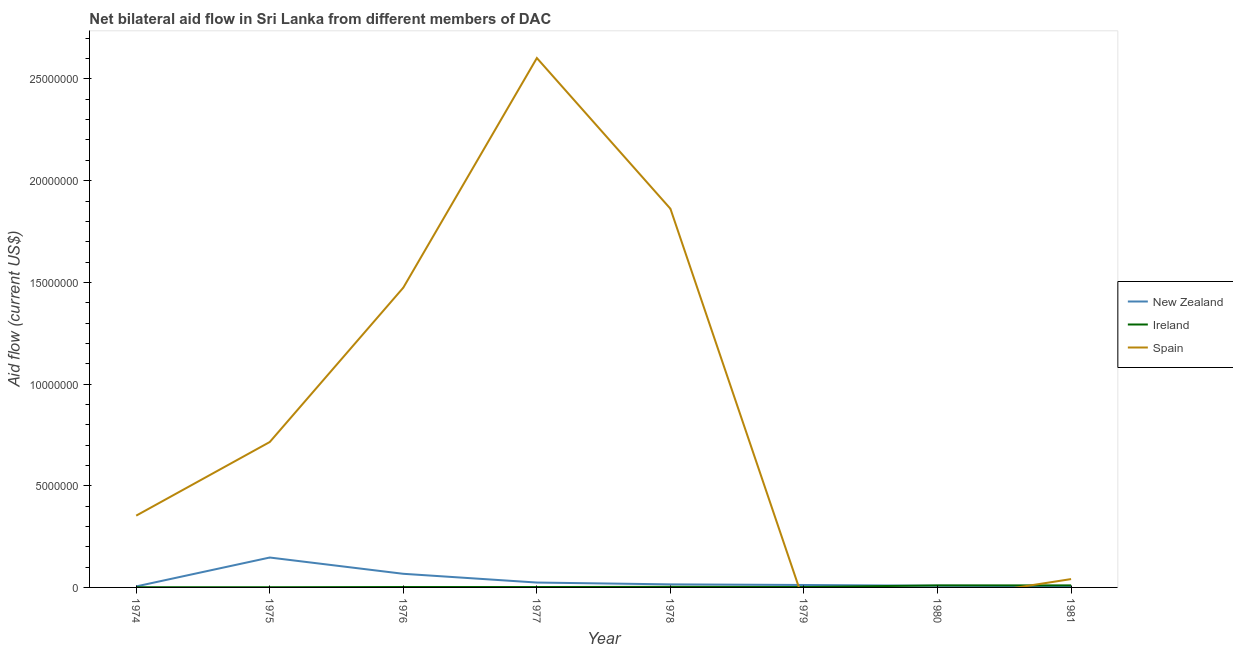How many different coloured lines are there?
Provide a succinct answer. 3. What is the amount of aid provided by new zealand in 1980?
Keep it short and to the point. 8.00e+04. Across all years, what is the maximum amount of aid provided by spain?
Offer a very short reply. 2.60e+07. Across all years, what is the minimum amount of aid provided by ireland?
Your response must be concise. 10000. In which year was the amount of aid provided by new zealand maximum?
Your answer should be compact. 1975. What is the total amount of aid provided by spain in the graph?
Provide a short and direct response. 7.05e+07. What is the difference between the amount of aid provided by ireland in 1974 and that in 1981?
Give a very brief answer. -9.00e+04. What is the difference between the amount of aid provided by spain in 1979 and the amount of aid provided by ireland in 1975?
Your answer should be compact. -10000. What is the average amount of aid provided by new zealand per year?
Make the answer very short. 3.55e+05. In the year 1978, what is the difference between the amount of aid provided by new zealand and amount of aid provided by spain?
Your answer should be very brief. -1.85e+07. In how many years, is the amount of aid provided by new zealand greater than 22000000 US$?
Ensure brevity in your answer.  0. Is the difference between the amount of aid provided by new zealand in 1976 and 1977 greater than the difference between the amount of aid provided by ireland in 1976 and 1977?
Your answer should be very brief. Yes. What is the difference between the highest and the second highest amount of aid provided by spain?
Your answer should be very brief. 7.41e+06. What is the difference between the highest and the lowest amount of aid provided by spain?
Your response must be concise. 2.60e+07. Is the sum of the amount of aid provided by ireland in 1975 and 1978 greater than the maximum amount of aid provided by new zealand across all years?
Your answer should be very brief. No. Does the amount of aid provided by ireland monotonically increase over the years?
Offer a very short reply. No. Is the amount of aid provided by spain strictly less than the amount of aid provided by ireland over the years?
Provide a short and direct response. No. How many years are there in the graph?
Your response must be concise. 8. Does the graph contain any zero values?
Provide a short and direct response. Yes. Does the graph contain grids?
Keep it short and to the point. No. Where does the legend appear in the graph?
Ensure brevity in your answer.  Center right. How are the legend labels stacked?
Provide a short and direct response. Vertical. What is the title of the graph?
Your answer should be very brief. Net bilateral aid flow in Sri Lanka from different members of DAC. What is the label or title of the Y-axis?
Your answer should be very brief. Aid flow (current US$). What is the Aid flow (current US$) in New Zealand in 1974?
Make the answer very short. 5.00e+04. What is the Aid flow (current US$) in Spain in 1974?
Make the answer very short. 3.53e+06. What is the Aid flow (current US$) of New Zealand in 1975?
Make the answer very short. 1.47e+06. What is the Aid flow (current US$) in Ireland in 1975?
Give a very brief answer. 10000. What is the Aid flow (current US$) in Spain in 1975?
Your answer should be very brief. 7.15e+06. What is the Aid flow (current US$) of New Zealand in 1976?
Keep it short and to the point. 6.70e+05. What is the Aid flow (current US$) of Spain in 1976?
Provide a short and direct response. 1.47e+07. What is the Aid flow (current US$) in Ireland in 1977?
Your answer should be compact. 2.00e+04. What is the Aid flow (current US$) in Spain in 1977?
Keep it short and to the point. 2.60e+07. What is the Aid flow (current US$) of Ireland in 1978?
Your answer should be compact. 3.00e+04. What is the Aid flow (current US$) of Spain in 1978?
Offer a terse response. 1.86e+07. What is the Aid flow (current US$) of Ireland in 1979?
Offer a terse response. 2.00e+04. What is the Aid flow (current US$) of New Zealand in 1980?
Give a very brief answer. 8.00e+04. What is the Aid flow (current US$) of Ireland in 1980?
Ensure brevity in your answer.  1.00e+05. What is the Aid flow (current US$) of Spain in 1980?
Offer a terse response. 0. What is the Aid flow (current US$) of New Zealand in 1981?
Give a very brief answer. 6.00e+04. What is the Aid flow (current US$) of Ireland in 1981?
Your answer should be very brief. 1.00e+05. Across all years, what is the maximum Aid flow (current US$) in New Zealand?
Your answer should be very brief. 1.47e+06. Across all years, what is the maximum Aid flow (current US$) of Spain?
Make the answer very short. 2.60e+07. Across all years, what is the minimum Aid flow (current US$) in New Zealand?
Ensure brevity in your answer.  5.00e+04. Across all years, what is the minimum Aid flow (current US$) in Spain?
Provide a succinct answer. 0. What is the total Aid flow (current US$) of New Zealand in the graph?
Your answer should be compact. 2.84e+06. What is the total Aid flow (current US$) in Ireland in the graph?
Offer a very short reply. 3.10e+05. What is the total Aid flow (current US$) of Spain in the graph?
Your answer should be very brief. 7.05e+07. What is the difference between the Aid flow (current US$) in New Zealand in 1974 and that in 1975?
Your answer should be compact. -1.42e+06. What is the difference between the Aid flow (current US$) of Ireland in 1974 and that in 1975?
Offer a very short reply. 0. What is the difference between the Aid flow (current US$) of Spain in 1974 and that in 1975?
Provide a short and direct response. -3.62e+06. What is the difference between the Aid flow (current US$) of New Zealand in 1974 and that in 1976?
Ensure brevity in your answer.  -6.20e+05. What is the difference between the Aid flow (current US$) in Ireland in 1974 and that in 1976?
Provide a short and direct response. -10000. What is the difference between the Aid flow (current US$) in Spain in 1974 and that in 1976?
Offer a very short reply. -1.12e+07. What is the difference between the Aid flow (current US$) of New Zealand in 1974 and that in 1977?
Provide a succinct answer. -1.90e+05. What is the difference between the Aid flow (current US$) in Spain in 1974 and that in 1977?
Your answer should be compact. -2.25e+07. What is the difference between the Aid flow (current US$) of New Zealand in 1974 and that in 1978?
Give a very brief answer. -1.00e+05. What is the difference between the Aid flow (current US$) in Ireland in 1974 and that in 1978?
Offer a very short reply. -2.00e+04. What is the difference between the Aid flow (current US$) in Spain in 1974 and that in 1978?
Your response must be concise. -1.51e+07. What is the difference between the Aid flow (current US$) of Ireland in 1974 and that in 1980?
Your response must be concise. -9.00e+04. What is the difference between the Aid flow (current US$) of Spain in 1974 and that in 1981?
Make the answer very short. 3.12e+06. What is the difference between the Aid flow (current US$) in New Zealand in 1975 and that in 1976?
Your answer should be compact. 8.00e+05. What is the difference between the Aid flow (current US$) of Spain in 1975 and that in 1976?
Provide a succinct answer. -7.59e+06. What is the difference between the Aid flow (current US$) of New Zealand in 1975 and that in 1977?
Provide a succinct answer. 1.23e+06. What is the difference between the Aid flow (current US$) of Ireland in 1975 and that in 1977?
Offer a terse response. -10000. What is the difference between the Aid flow (current US$) in Spain in 1975 and that in 1977?
Offer a very short reply. -1.89e+07. What is the difference between the Aid flow (current US$) in New Zealand in 1975 and that in 1978?
Your response must be concise. 1.32e+06. What is the difference between the Aid flow (current US$) of Ireland in 1975 and that in 1978?
Offer a terse response. -2.00e+04. What is the difference between the Aid flow (current US$) in Spain in 1975 and that in 1978?
Provide a short and direct response. -1.15e+07. What is the difference between the Aid flow (current US$) in New Zealand in 1975 and that in 1979?
Your response must be concise. 1.35e+06. What is the difference between the Aid flow (current US$) in New Zealand in 1975 and that in 1980?
Provide a short and direct response. 1.39e+06. What is the difference between the Aid flow (current US$) in Ireland in 1975 and that in 1980?
Your answer should be compact. -9.00e+04. What is the difference between the Aid flow (current US$) of New Zealand in 1975 and that in 1981?
Your answer should be compact. 1.41e+06. What is the difference between the Aid flow (current US$) of Spain in 1975 and that in 1981?
Offer a very short reply. 6.74e+06. What is the difference between the Aid flow (current US$) of New Zealand in 1976 and that in 1977?
Your answer should be compact. 4.30e+05. What is the difference between the Aid flow (current US$) of Ireland in 1976 and that in 1977?
Keep it short and to the point. 0. What is the difference between the Aid flow (current US$) in Spain in 1976 and that in 1977?
Offer a very short reply. -1.13e+07. What is the difference between the Aid flow (current US$) of New Zealand in 1976 and that in 1978?
Keep it short and to the point. 5.20e+05. What is the difference between the Aid flow (current US$) of Spain in 1976 and that in 1978?
Your answer should be compact. -3.88e+06. What is the difference between the Aid flow (current US$) in New Zealand in 1976 and that in 1980?
Provide a succinct answer. 5.90e+05. What is the difference between the Aid flow (current US$) of Ireland in 1976 and that in 1981?
Ensure brevity in your answer.  -8.00e+04. What is the difference between the Aid flow (current US$) of Spain in 1976 and that in 1981?
Ensure brevity in your answer.  1.43e+07. What is the difference between the Aid flow (current US$) in Spain in 1977 and that in 1978?
Your response must be concise. 7.41e+06. What is the difference between the Aid flow (current US$) in New Zealand in 1977 and that in 1979?
Your answer should be compact. 1.20e+05. What is the difference between the Aid flow (current US$) of New Zealand in 1977 and that in 1981?
Offer a very short reply. 1.80e+05. What is the difference between the Aid flow (current US$) in Ireland in 1977 and that in 1981?
Provide a short and direct response. -8.00e+04. What is the difference between the Aid flow (current US$) in Spain in 1977 and that in 1981?
Your answer should be very brief. 2.56e+07. What is the difference between the Aid flow (current US$) of New Zealand in 1978 and that in 1979?
Provide a succinct answer. 3.00e+04. What is the difference between the Aid flow (current US$) of Ireland in 1978 and that in 1980?
Provide a short and direct response. -7.00e+04. What is the difference between the Aid flow (current US$) in Ireland in 1978 and that in 1981?
Offer a terse response. -7.00e+04. What is the difference between the Aid flow (current US$) in Spain in 1978 and that in 1981?
Offer a very short reply. 1.82e+07. What is the difference between the Aid flow (current US$) of New Zealand in 1979 and that in 1980?
Your response must be concise. 4.00e+04. What is the difference between the Aid flow (current US$) of Ireland in 1979 and that in 1980?
Keep it short and to the point. -8.00e+04. What is the difference between the Aid flow (current US$) of New Zealand in 1979 and that in 1981?
Ensure brevity in your answer.  6.00e+04. What is the difference between the Aid flow (current US$) in Ireland in 1979 and that in 1981?
Offer a very short reply. -8.00e+04. What is the difference between the Aid flow (current US$) in New Zealand in 1974 and the Aid flow (current US$) in Ireland in 1975?
Provide a short and direct response. 4.00e+04. What is the difference between the Aid flow (current US$) of New Zealand in 1974 and the Aid flow (current US$) of Spain in 1975?
Your response must be concise. -7.10e+06. What is the difference between the Aid flow (current US$) in Ireland in 1974 and the Aid flow (current US$) in Spain in 1975?
Make the answer very short. -7.14e+06. What is the difference between the Aid flow (current US$) of New Zealand in 1974 and the Aid flow (current US$) of Ireland in 1976?
Give a very brief answer. 3.00e+04. What is the difference between the Aid flow (current US$) in New Zealand in 1974 and the Aid flow (current US$) in Spain in 1976?
Offer a very short reply. -1.47e+07. What is the difference between the Aid flow (current US$) of Ireland in 1974 and the Aid flow (current US$) of Spain in 1976?
Offer a very short reply. -1.47e+07. What is the difference between the Aid flow (current US$) of New Zealand in 1974 and the Aid flow (current US$) of Spain in 1977?
Your response must be concise. -2.60e+07. What is the difference between the Aid flow (current US$) of Ireland in 1974 and the Aid flow (current US$) of Spain in 1977?
Your answer should be very brief. -2.60e+07. What is the difference between the Aid flow (current US$) in New Zealand in 1974 and the Aid flow (current US$) in Spain in 1978?
Ensure brevity in your answer.  -1.86e+07. What is the difference between the Aid flow (current US$) of Ireland in 1974 and the Aid flow (current US$) of Spain in 1978?
Offer a terse response. -1.86e+07. What is the difference between the Aid flow (current US$) of New Zealand in 1974 and the Aid flow (current US$) of Ireland in 1979?
Give a very brief answer. 3.00e+04. What is the difference between the Aid flow (current US$) in New Zealand in 1974 and the Aid flow (current US$) in Ireland in 1981?
Your answer should be compact. -5.00e+04. What is the difference between the Aid flow (current US$) of New Zealand in 1974 and the Aid flow (current US$) of Spain in 1981?
Provide a short and direct response. -3.60e+05. What is the difference between the Aid flow (current US$) of Ireland in 1974 and the Aid flow (current US$) of Spain in 1981?
Ensure brevity in your answer.  -4.00e+05. What is the difference between the Aid flow (current US$) in New Zealand in 1975 and the Aid flow (current US$) in Ireland in 1976?
Make the answer very short. 1.45e+06. What is the difference between the Aid flow (current US$) of New Zealand in 1975 and the Aid flow (current US$) of Spain in 1976?
Offer a terse response. -1.33e+07. What is the difference between the Aid flow (current US$) of Ireland in 1975 and the Aid flow (current US$) of Spain in 1976?
Your response must be concise. -1.47e+07. What is the difference between the Aid flow (current US$) in New Zealand in 1975 and the Aid flow (current US$) in Ireland in 1977?
Make the answer very short. 1.45e+06. What is the difference between the Aid flow (current US$) in New Zealand in 1975 and the Aid flow (current US$) in Spain in 1977?
Make the answer very short. -2.46e+07. What is the difference between the Aid flow (current US$) of Ireland in 1975 and the Aid flow (current US$) of Spain in 1977?
Your answer should be very brief. -2.60e+07. What is the difference between the Aid flow (current US$) in New Zealand in 1975 and the Aid flow (current US$) in Ireland in 1978?
Ensure brevity in your answer.  1.44e+06. What is the difference between the Aid flow (current US$) of New Zealand in 1975 and the Aid flow (current US$) of Spain in 1978?
Give a very brief answer. -1.72e+07. What is the difference between the Aid flow (current US$) in Ireland in 1975 and the Aid flow (current US$) in Spain in 1978?
Keep it short and to the point. -1.86e+07. What is the difference between the Aid flow (current US$) of New Zealand in 1975 and the Aid flow (current US$) of Ireland in 1979?
Keep it short and to the point. 1.45e+06. What is the difference between the Aid flow (current US$) of New Zealand in 1975 and the Aid flow (current US$) of Ireland in 1980?
Provide a short and direct response. 1.37e+06. What is the difference between the Aid flow (current US$) in New Zealand in 1975 and the Aid flow (current US$) in Ireland in 1981?
Provide a succinct answer. 1.37e+06. What is the difference between the Aid flow (current US$) in New Zealand in 1975 and the Aid flow (current US$) in Spain in 1981?
Provide a succinct answer. 1.06e+06. What is the difference between the Aid flow (current US$) in Ireland in 1975 and the Aid flow (current US$) in Spain in 1981?
Your answer should be very brief. -4.00e+05. What is the difference between the Aid flow (current US$) of New Zealand in 1976 and the Aid flow (current US$) of Ireland in 1977?
Ensure brevity in your answer.  6.50e+05. What is the difference between the Aid flow (current US$) of New Zealand in 1976 and the Aid flow (current US$) of Spain in 1977?
Your answer should be compact. -2.54e+07. What is the difference between the Aid flow (current US$) of Ireland in 1976 and the Aid flow (current US$) of Spain in 1977?
Offer a very short reply. -2.60e+07. What is the difference between the Aid flow (current US$) in New Zealand in 1976 and the Aid flow (current US$) in Ireland in 1978?
Make the answer very short. 6.40e+05. What is the difference between the Aid flow (current US$) of New Zealand in 1976 and the Aid flow (current US$) of Spain in 1978?
Your answer should be compact. -1.80e+07. What is the difference between the Aid flow (current US$) in Ireland in 1976 and the Aid flow (current US$) in Spain in 1978?
Your answer should be very brief. -1.86e+07. What is the difference between the Aid flow (current US$) of New Zealand in 1976 and the Aid flow (current US$) of Ireland in 1979?
Ensure brevity in your answer.  6.50e+05. What is the difference between the Aid flow (current US$) of New Zealand in 1976 and the Aid flow (current US$) of Ireland in 1980?
Offer a very short reply. 5.70e+05. What is the difference between the Aid flow (current US$) in New Zealand in 1976 and the Aid flow (current US$) in Ireland in 1981?
Your answer should be compact. 5.70e+05. What is the difference between the Aid flow (current US$) of Ireland in 1976 and the Aid flow (current US$) of Spain in 1981?
Keep it short and to the point. -3.90e+05. What is the difference between the Aid flow (current US$) of New Zealand in 1977 and the Aid flow (current US$) of Ireland in 1978?
Keep it short and to the point. 2.10e+05. What is the difference between the Aid flow (current US$) in New Zealand in 1977 and the Aid flow (current US$) in Spain in 1978?
Ensure brevity in your answer.  -1.84e+07. What is the difference between the Aid flow (current US$) in Ireland in 1977 and the Aid flow (current US$) in Spain in 1978?
Offer a very short reply. -1.86e+07. What is the difference between the Aid flow (current US$) in New Zealand in 1977 and the Aid flow (current US$) in Ireland in 1979?
Your answer should be very brief. 2.20e+05. What is the difference between the Aid flow (current US$) in New Zealand in 1977 and the Aid flow (current US$) in Spain in 1981?
Make the answer very short. -1.70e+05. What is the difference between the Aid flow (current US$) of Ireland in 1977 and the Aid flow (current US$) of Spain in 1981?
Your response must be concise. -3.90e+05. What is the difference between the Aid flow (current US$) of New Zealand in 1978 and the Aid flow (current US$) of Ireland in 1979?
Provide a succinct answer. 1.30e+05. What is the difference between the Aid flow (current US$) in New Zealand in 1978 and the Aid flow (current US$) in Ireland in 1981?
Give a very brief answer. 5.00e+04. What is the difference between the Aid flow (current US$) of Ireland in 1978 and the Aid flow (current US$) of Spain in 1981?
Offer a terse response. -3.80e+05. What is the difference between the Aid flow (current US$) of New Zealand in 1979 and the Aid flow (current US$) of Ireland in 1980?
Offer a terse response. 2.00e+04. What is the difference between the Aid flow (current US$) in Ireland in 1979 and the Aid flow (current US$) in Spain in 1981?
Offer a very short reply. -3.90e+05. What is the difference between the Aid flow (current US$) in New Zealand in 1980 and the Aid flow (current US$) in Ireland in 1981?
Your answer should be compact. -2.00e+04. What is the difference between the Aid flow (current US$) in New Zealand in 1980 and the Aid flow (current US$) in Spain in 1981?
Provide a short and direct response. -3.30e+05. What is the difference between the Aid flow (current US$) of Ireland in 1980 and the Aid flow (current US$) of Spain in 1981?
Ensure brevity in your answer.  -3.10e+05. What is the average Aid flow (current US$) of New Zealand per year?
Ensure brevity in your answer.  3.55e+05. What is the average Aid flow (current US$) of Ireland per year?
Provide a short and direct response. 3.88e+04. What is the average Aid flow (current US$) in Spain per year?
Your response must be concise. 8.81e+06. In the year 1974, what is the difference between the Aid flow (current US$) in New Zealand and Aid flow (current US$) in Ireland?
Give a very brief answer. 4.00e+04. In the year 1974, what is the difference between the Aid flow (current US$) of New Zealand and Aid flow (current US$) of Spain?
Make the answer very short. -3.48e+06. In the year 1974, what is the difference between the Aid flow (current US$) of Ireland and Aid flow (current US$) of Spain?
Keep it short and to the point. -3.52e+06. In the year 1975, what is the difference between the Aid flow (current US$) in New Zealand and Aid flow (current US$) in Ireland?
Offer a very short reply. 1.46e+06. In the year 1975, what is the difference between the Aid flow (current US$) of New Zealand and Aid flow (current US$) of Spain?
Keep it short and to the point. -5.68e+06. In the year 1975, what is the difference between the Aid flow (current US$) of Ireland and Aid flow (current US$) of Spain?
Make the answer very short. -7.14e+06. In the year 1976, what is the difference between the Aid flow (current US$) of New Zealand and Aid flow (current US$) of Ireland?
Provide a succinct answer. 6.50e+05. In the year 1976, what is the difference between the Aid flow (current US$) of New Zealand and Aid flow (current US$) of Spain?
Ensure brevity in your answer.  -1.41e+07. In the year 1976, what is the difference between the Aid flow (current US$) of Ireland and Aid flow (current US$) of Spain?
Keep it short and to the point. -1.47e+07. In the year 1977, what is the difference between the Aid flow (current US$) in New Zealand and Aid flow (current US$) in Ireland?
Provide a short and direct response. 2.20e+05. In the year 1977, what is the difference between the Aid flow (current US$) of New Zealand and Aid flow (current US$) of Spain?
Offer a terse response. -2.58e+07. In the year 1977, what is the difference between the Aid flow (current US$) in Ireland and Aid flow (current US$) in Spain?
Give a very brief answer. -2.60e+07. In the year 1978, what is the difference between the Aid flow (current US$) in New Zealand and Aid flow (current US$) in Ireland?
Offer a very short reply. 1.20e+05. In the year 1978, what is the difference between the Aid flow (current US$) of New Zealand and Aid flow (current US$) of Spain?
Offer a very short reply. -1.85e+07. In the year 1978, what is the difference between the Aid flow (current US$) of Ireland and Aid flow (current US$) of Spain?
Offer a terse response. -1.86e+07. In the year 1980, what is the difference between the Aid flow (current US$) of New Zealand and Aid flow (current US$) of Ireland?
Your response must be concise. -2.00e+04. In the year 1981, what is the difference between the Aid flow (current US$) of New Zealand and Aid flow (current US$) of Ireland?
Provide a succinct answer. -4.00e+04. In the year 1981, what is the difference between the Aid flow (current US$) of New Zealand and Aid flow (current US$) of Spain?
Your answer should be compact. -3.50e+05. In the year 1981, what is the difference between the Aid flow (current US$) in Ireland and Aid flow (current US$) in Spain?
Give a very brief answer. -3.10e+05. What is the ratio of the Aid flow (current US$) of New Zealand in 1974 to that in 1975?
Provide a short and direct response. 0.03. What is the ratio of the Aid flow (current US$) in Spain in 1974 to that in 1975?
Offer a terse response. 0.49. What is the ratio of the Aid flow (current US$) in New Zealand in 1974 to that in 1976?
Make the answer very short. 0.07. What is the ratio of the Aid flow (current US$) of Spain in 1974 to that in 1976?
Your answer should be compact. 0.24. What is the ratio of the Aid flow (current US$) of New Zealand in 1974 to that in 1977?
Provide a succinct answer. 0.21. What is the ratio of the Aid flow (current US$) of Spain in 1974 to that in 1977?
Your response must be concise. 0.14. What is the ratio of the Aid flow (current US$) of Ireland in 1974 to that in 1978?
Ensure brevity in your answer.  0.33. What is the ratio of the Aid flow (current US$) of Spain in 1974 to that in 1978?
Keep it short and to the point. 0.19. What is the ratio of the Aid flow (current US$) of New Zealand in 1974 to that in 1979?
Offer a very short reply. 0.42. What is the ratio of the Aid flow (current US$) of Ireland in 1974 to that in 1979?
Your response must be concise. 0.5. What is the ratio of the Aid flow (current US$) in Spain in 1974 to that in 1981?
Provide a succinct answer. 8.61. What is the ratio of the Aid flow (current US$) of New Zealand in 1975 to that in 1976?
Your answer should be compact. 2.19. What is the ratio of the Aid flow (current US$) in Spain in 1975 to that in 1976?
Your response must be concise. 0.49. What is the ratio of the Aid flow (current US$) of New Zealand in 1975 to that in 1977?
Your response must be concise. 6.12. What is the ratio of the Aid flow (current US$) of Spain in 1975 to that in 1977?
Your answer should be compact. 0.27. What is the ratio of the Aid flow (current US$) in New Zealand in 1975 to that in 1978?
Offer a very short reply. 9.8. What is the ratio of the Aid flow (current US$) of Spain in 1975 to that in 1978?
Your response must be concise. 0.38. What is the ratio of the Aid flow (current US$) in New Zealand in 1975 to that in 1979?
Provide a short and direct response. 12.25. What is the ratio of the Aid flow (current US$) of New Zealand in 1975 to that in 1980?
Make the answer very short. 18.38. What is the ratio of the Aid flow (current US$) in Spain in 1975 to that in 1981?
Make the answer very short. 17.44. What is the ratio of the Aid flow (current US$) of New Zealand in 1976 to that in 1977?
Your response must be concise. 2.79. What is the ratio of the Aid flow (current US$) in Spain in 1976 to that in 1977?
Make the answer very short. 0.57. What is the ratio of the Aid flow (current US$) in New Zealand in 1976 to that in 1978?
Your answer should be very brief. 4.47. What is the ratio of the Aid flow (current US$) of Ireland in 1976 to that in 1978?
Provide a succinct answer. 0.67. What is the ratio of the Aid flow (current US$) in Spain in 1976 to that in 1978?
Offer a terse response. 0.79. What is the ratio of the Aid flow (current US$) in New Zealand in 1976 to that in 1979?
Keep it short and to the point. 5.58. What is the ratio of the Aid flow (current US$) in New Zealand in 1976 to that in 1980?
Give a very brief answer. 8.38. What is the ratio of the Aid flow (current US$) of Ireland in 1976 to that in 1980?
Give a very brief answer. 0.2. What is the ratio of the Aid flow (current US$) of New Zealand in 1976 to that in 1981?
Ensure brevity in your answer.  11.17. What is the ratio of the Aid flow (current US$) in Spain in 1976 to that in 1981?
Your answer should be very brief. 35.95. What is the ratio of the Aid flow (current US$) in Spain in 1977 to that in 1978?
Keep it short and to the point. 1.4. What is the ratio of the Aid flow (current US$) in New Zealand in 1977 to that in 1979?
Your answer should be very brief. 2. What is the ratio of the Aid flow (current US$) of Spain in 1977 to that in 1981?
Your response must be concise. 63.49. What is the ratio of the Aid flow (current US$) of New Zealand in 1978 to that in 1979?
Keep it short and to the point. 1.25. What is the ratio of the Aid flow (current US$) of Ireland in 1978 to that in 1979?
Your answer should be compact. 1.5. What is the ratio of the Aid flow (current US$) in New Zealand in 1978 to that in 1980?
Offer a very short reply. 1.88. What is the ratio of the Aid flow (current US$) of Spain in 1978 to that in 1981?
Keep it short and to the point. 45.41. What is the ratio of the Aid flow (current US$) of New Zealand in 1979 to that in 1980?
Your answer should be very brief. 1.5. What is the ratio of the Aid flow (current US$) of Ireland in 1979 to that in 1981?
Ensure brevity in your answer.  0.2. What is the ratio of the Aid flow (current US$) of New Zealand in 1980 to that in 1981?
Provide a succinct answer. 1.33. What is the ratio of the Aid flow (current US$) in Ireland in 1980 to that in 1981?
Give a very brief answer. 1. What is the difference between the highest and the second highest Aid flow (current US$) in New Zealand?
Offer a very short reply. 8.00e+05. What is the difference between the highest and the second highest Aid flow (current US$) of Ireland?
Give a very brief answer. 0. What is the difference between the highest and the second highest Aid flow (current US$) of Spain?
Your response must be concise. 7.41e+06. What is the difference between the highest and the lowest Aid flow (current US$) of New Zealand?
Make the answer very short. 1.42e+06. What is the difference between the highest and the lowest Aid flow (current US$) of Ireland?
Keep it short and to the point. 9.00e+04. What is the difference between the highest and the lowest Aid flow (current US$) of Spain?
Keep it short and to the point. 2.60e+07. 